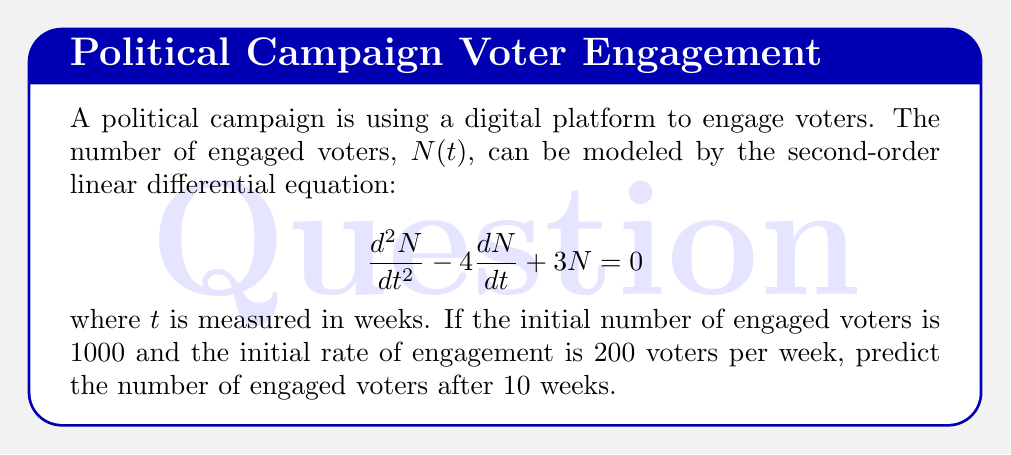Can you solve this math problem? To solve this problem, we need to follow these steps:

1) The general solution for this second-order linear differential equation is:

   $$N(t) = C_1e^{3t} + C_2e^t$$

2) We need to find $C_1$ and $C_2$ using the initial conditions:
   
   At $t=0$, $N(0) = 1000$ and $\frac{dN}{dt}(0) = 200$

3) Using the first condition:

   $$1000 = C_1 + C_2$$

4) For the second condition, we differentiate $N(t)$:

   $$\frac{dN}{dt} = 3C_1e^{3t} + C_2e^t$$

   At $t=0$:
   
   $$200 = 3C_1 + C_2$$

5) Now we have a system of two equations:

   $$C_1 + C_2 = 1000$$
   $$3C_1 + C_2 = 200$$

6) Subtracting the second equation from the first:

   $$-2C_1 = 800$$
   $$C_1 = -400$$

7) Substituting this back into the first equation:

   $$-400 + C_2 = 1000$$
   $$C_2 = 1400$$

8) Therefore, our particular solution is:

   $$N(t) = -400e^{3t} + 1400e^t$$

9) To find $N(10)$, we substitute $t=10$:

   $$N(10) = -400e^{30} + 1400e^{10}$$

10) Using a calculator to evaluate this expression:

    $$N(10) \approx 9,321,528$$
Answer: After 10 weeks, the predicted number of engaged voters is approximately 9,321,528. 